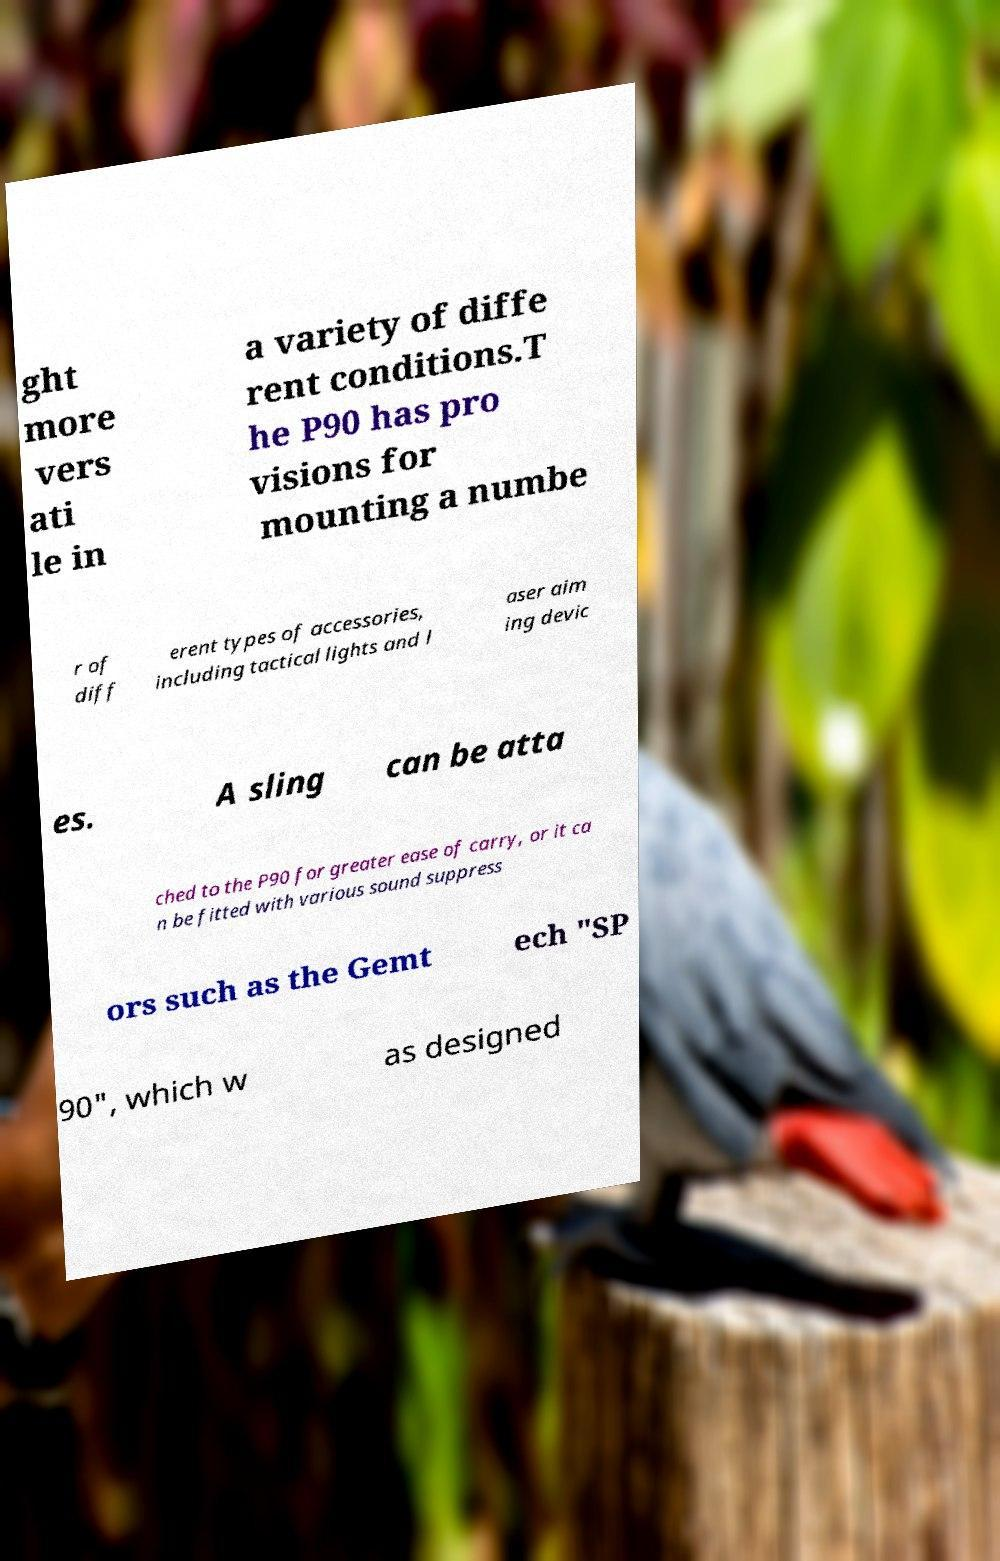For documentation purposes, I need the text within this image transcribed. Could you provide that? ght more vers ati le in a variety of diffe rent conditions.T he P90 has pro visions for mounting a numbe r of diff erent types of accessories, including tactical lights and l aser aim ing devic es. A sling can be atta ched to the P90 for greater ease of carry, or it ca n be fitted with various sound suppress ors such as the Gemt ech "SP 90", which w as designed 